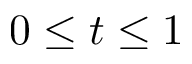<formula> <loc_0><loc_0><loc_500><loc_500>0 \leq t \leq 1</formula> 